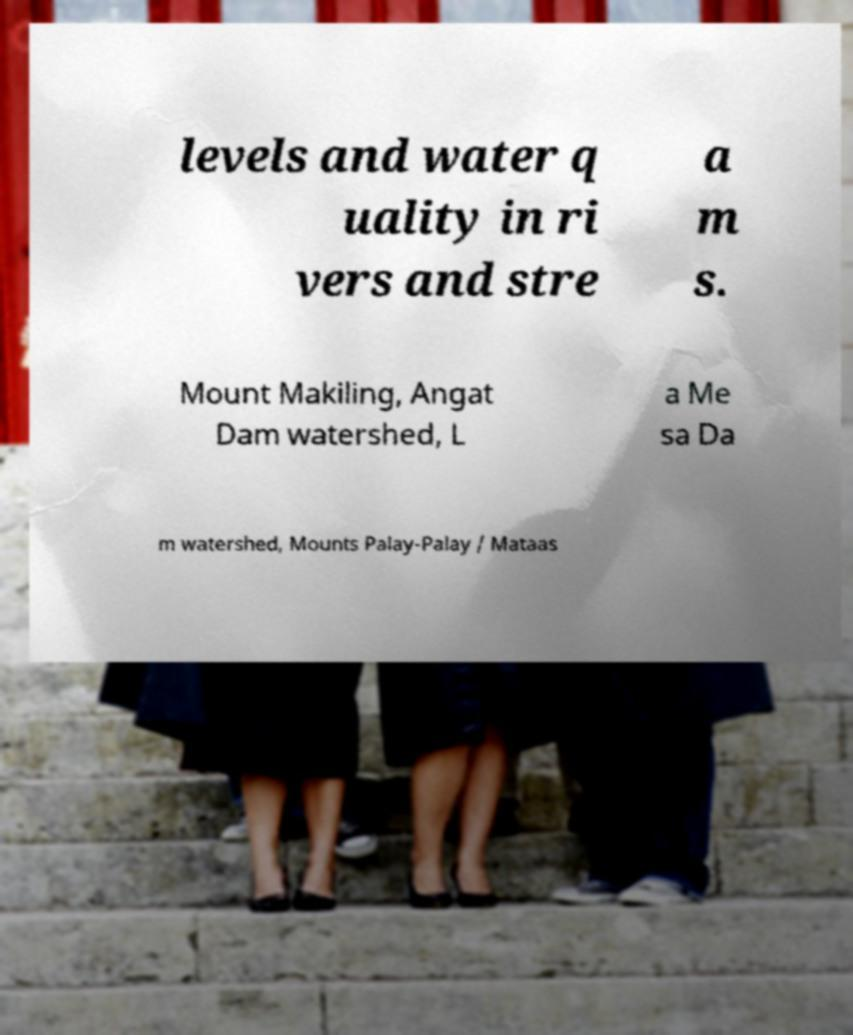Can you read and provide the text displayed in the image?This photo seems to have some interesting text. Can you extract and type it out for me? levels and water q uality in ri vers and stre a m s. Mount Makiling, Angat Dam watershed, L a Me sa Da m watershed, Mounts Palay-Palay / Mataas 